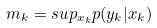<formula> <loc_0><loc_0><loc_500><loc_500>m _ { k } = s u p _ { x _ { k } } p ( y _ { k } | x _ { k } )</formula> 